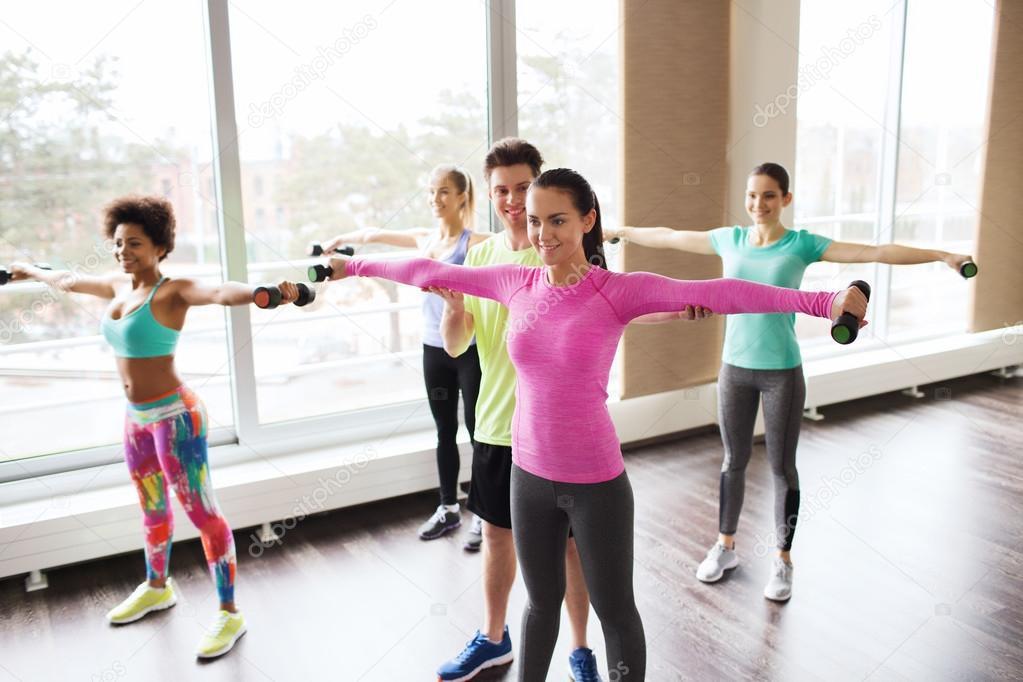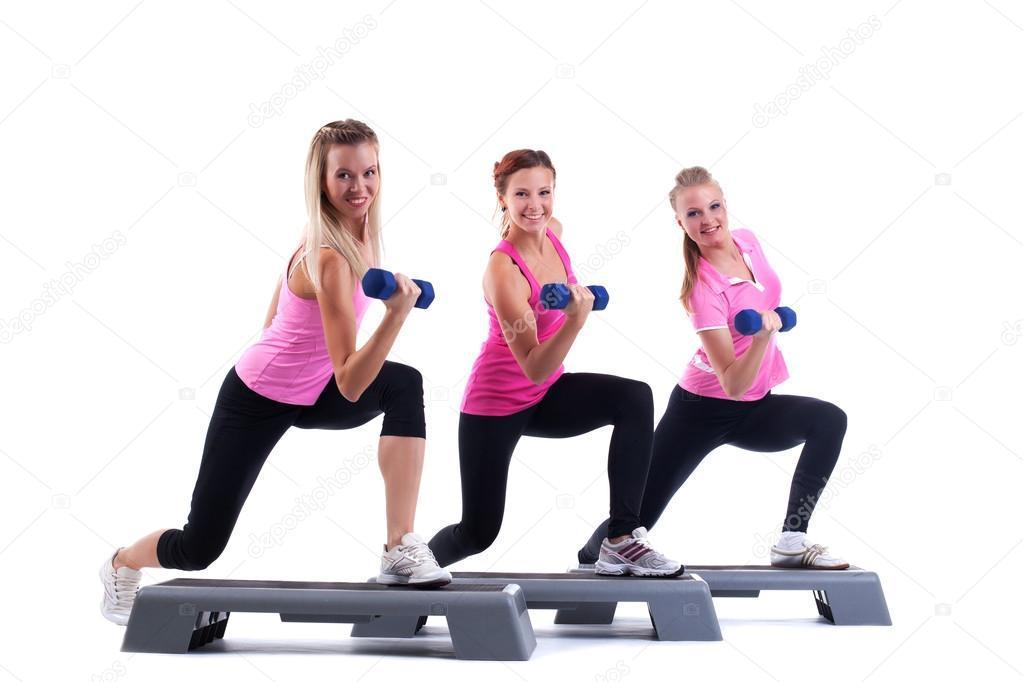The first image is the image on the left, the second image is the image on the right. Examine the images to the left and right. Is the description "One image shows a man holding something weighted in each hand, standing in front of at least four women doing the same workout." accurate? Answer yes or no. No. The first image is the image on the left, the second image is the image on the right. Given the left and right images, does the statement "In at least one image there are three people lifting weights." hold true? Answer yes or no. Yes. 